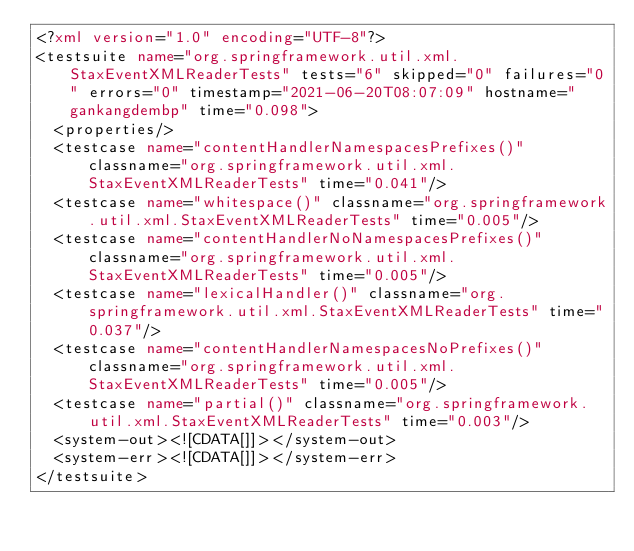<code> <loc_0><loc_0><loc_500><loc_500><_XML_><?xml version="1.0" encoding="UTF-8"?>
<testsuite name="org.springframework.util.xml.StaxEventXMLReaderTests" tests="6" skipped="0" failures="0" errors="0" timestamp="2021-06-20T08:07:09" hostname="gankangdembp" time="0.098">
  <properties/>
  <testcase name="contentHandlerNamespacesPrefixes()" classname="org.springframework.util.xml.StaxEventXMLReaderTests" time="0.041"/>
  <testcase name="whitespace()" classname="org.springframework.util.xml.StaxEventXMLReaderTests" time="0.005"/>
  <testcase name="contentHandlerNoNamespacesPrefixes()" classname="org.springframework.util.xml.StaxEventXMLReaderTests" time="0.005"/>
  <testcase name="lexicalHandler()" classname="org.springframework.util.xml.StaxEventXMLReaderTests" time="0.037"/>
  <testcase name="contentHandlerNamespacesNoPrefixes()" classname="org.springframework.util.xml.StaxEventXMLReaderTests" time="0.005"/>
  <testcase name="partial()" classname="org.springframework.util.xml.StaxEventXMLReaderTests" time="0.003"/>
  <system-out><![CDATA[]]></system-out>
  <system-err><![CDATA[]]></system-err>
</testsuite>
</code> 